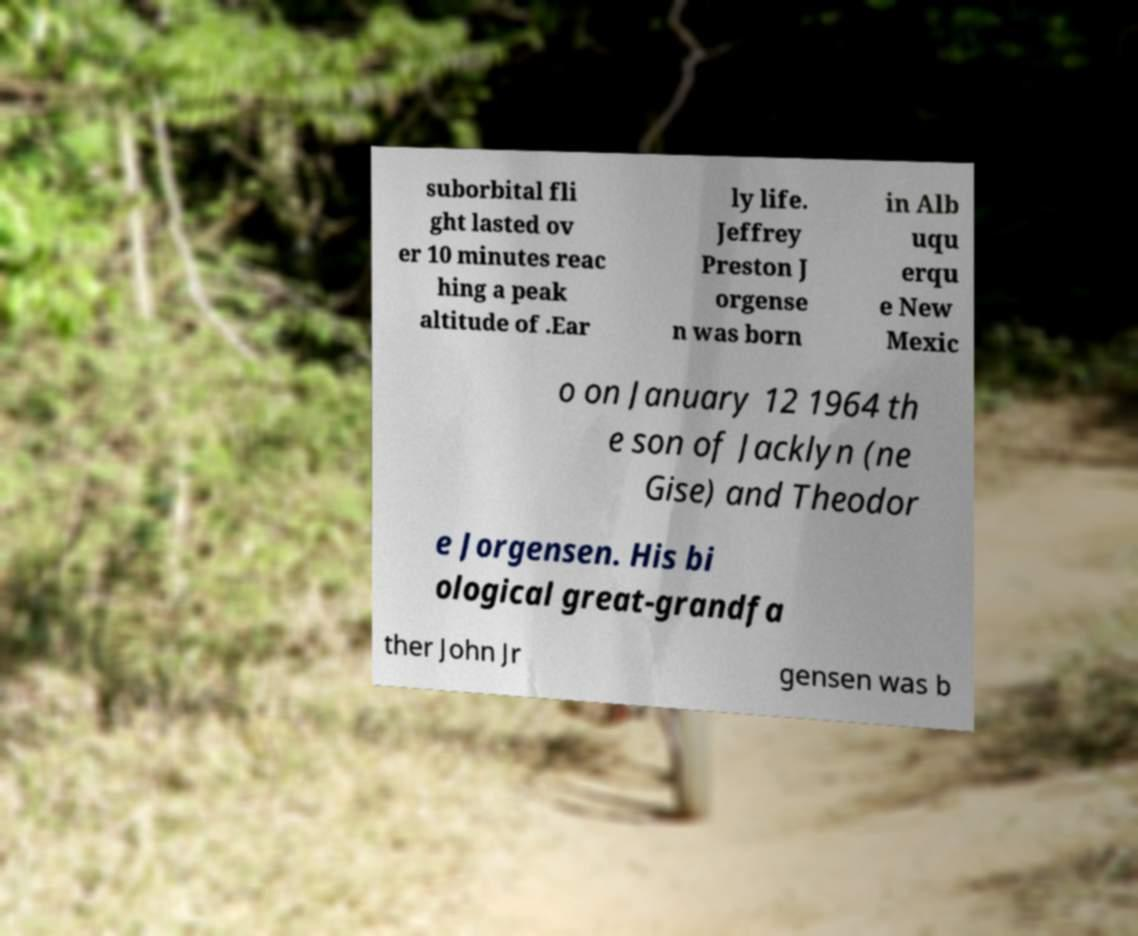Can you accurately transcribe the text from the provided image for me? suborbital fli ght lasted ov er 10 minutes reac hing a peak altitude of .Ear ly life. Jeffrey Preston J orgense n was born in Alb uqu erqu e New Mexic o on January 12 1964 th e son of Jacklyn (ne Gise) and Theodor e Jorgensen. His bi ological great-grandfa ther John Jr gensen was b 